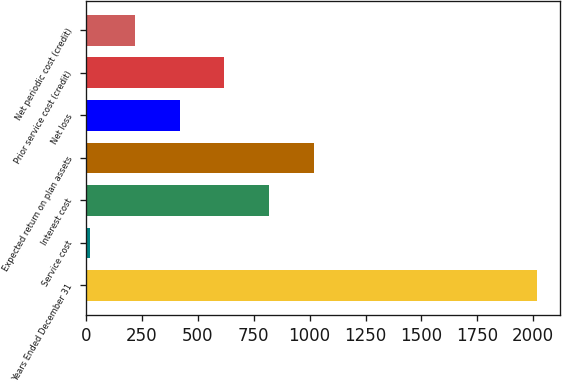Convert chart to OTSL. <chart><loc_0><loc_0><loc_500><loc_500><bar_chart><fcel>Years Ended December 31<fcel>Service cost<fcel>Interest cost<fcel>Expected return on plan assets<fcel>Net loss<fcel>Prior service cost (credit)<fcel>Net periodic cost (credit)<nl><fcel>2017<fcel>19<fcel>818.2<fcel>1018<fcel>418.6<fcel>618.4<fcel>218.8<nl></chart> 